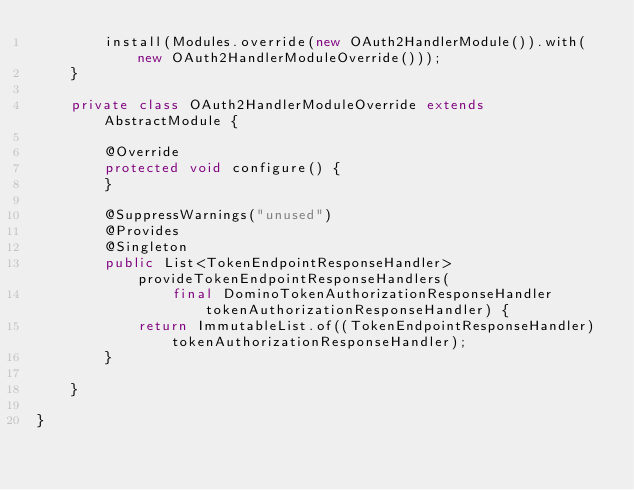<code> <loc_0><loc_0><loc_500><loc_500><_Java_>		install(Modules.override(new OAuth2HandlerModule()).with(new OAuth2HandlerModuleOverride()));
	}
	
	private class OAuth2HandlerModuleOverride extends AbstractModule {

		@Override
		protected void configure() {
		}

		@SuppressWarnings("unused")
		@Provides
		@Singleton
		public List<TokenEndpointResponseHandler> provideTokenEndpointResponseHandlers(
				final DominoTokenAuthorizationResponseHandler tokenAuthorizationResponseHandler) {
			return ImmutableList.of((TokenEndpointResponseHandler) tokenAuthorizationResponseHandler);
		}

	}

}
</code> 